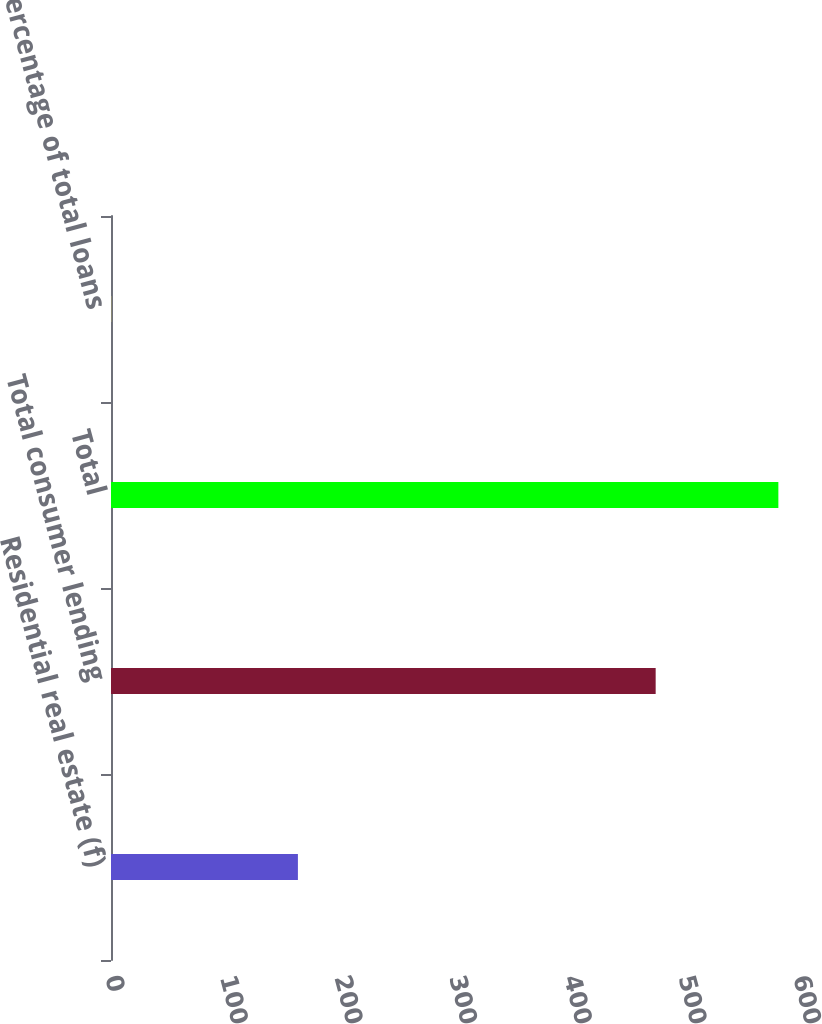Convert chart to OTSL. <chart><loc_0><loc_0><loc_500><loc_500><bar_chart><fcel>Residential real estate (f)<fcel>Total consumer lending<fcel>Total<fcel>Percentage of total loans<nl><fcel>163<fcel>475<fcel>582<fcel>0.28<nl></chart> 